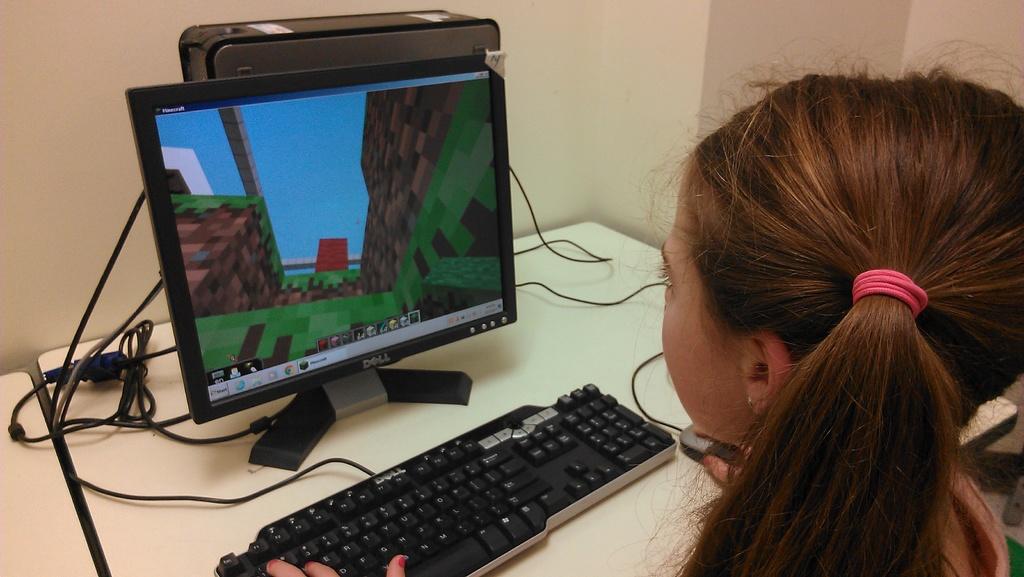What is the brand of the monitor?
Ensure brevity in your answer.  Dell. What word is displayed in white on the top left of the girl's screen?
Give a very brief answer. Unanswerable. 